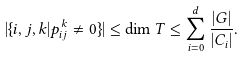Convert formula to latex. <formula><loc_0><loc_0><loc_500><loc_500>| \{ i , j , k | p _ { i j } ^ { k } \neq 0 \} | \leq \dim T \leq \sum _ { i = 0 } ^ { d } \frac { | G | } { | C _ { i } | } .</formula> 